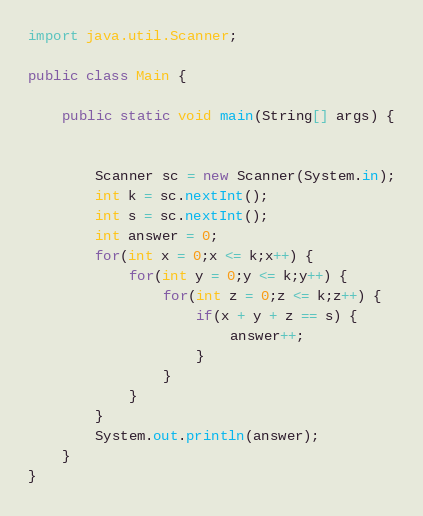Convert code to text. <code><loc_0><loc_0><loc_500><loc_500><_Java_>import java.util.Scanner;

public class Main {

	public static void main(String[] args) {


		Scanner sc = new Scanner(System.in);
		int k = sc.nextInt();
		int s = sc.nextInt();
		int answer = 0;
		for(int x = 0;x <= k;x++) {
			for(int y = 0;y <= k;y++) {
				for(int z = 0;z <= k;z++) {
					if(x + y + z == s) {
						answer++;
					}
				}
			}
		}
		System.out.println(answer);
	}
}</code> 